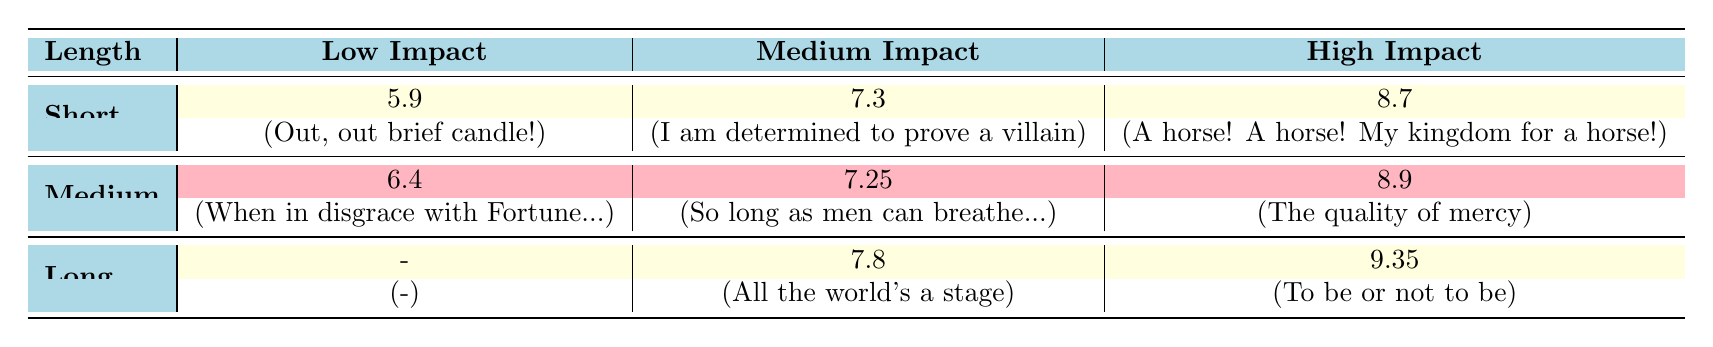What is the audience feedback score for "To be or not to be"? The score for "To be or not to be" is found under the High Impact category in the Long length section of the table, which shows a score of 9.5.
Answer: 9.5 Which emotional impact has the highest rating in the short length category? In the Short length section, the High Impact score is significantly higher than the others, with a score of 8.7 for "A horse! A horse! My kingdom for a horse!".
Answer: High What is the average audience feedback score for medium impact monologues? The medium impact monologues scores are 7.3, 7.25, and 7.8. Summing these gives 22.35, and dividing by 3 gives an average of 7.45.
Answer: 7.45 Is there a low impact monologue with a score higher than 6? "When in disgrace with Fortune and men's eyes" has a score of 6.4, which is greater than 6. Therefore, it is true.
Answer: Yes Which monologue has the shortest length with high emotional impact? The Short length category features one high impact monologue, "A horse! A horse! My kingdom for a horse!", which is 50 seconds long.
Answer: A horse! A horse! My kingdom for a horse! What is the difference in audience feedback scores between the highest and lowest in the low impact category? The highest score in the low impact category is 6.4 for "When in disgrace with Fortune and men's eyes", and the lowest is 5.9 for "Out, out brief candle!". The difference is 6.4 - 5.9 = 0.5.
Answer: 0.5 How many monologues are there in total with a medium emotional impact? The table lists 3 medium impact monologues: "I am determined to prove a villain", "So long as men can breathe or eyes can see", and "All the world's a stage". Thus, there are 3.
Answer: 3 Which emotional impact category has the largest average score across length categories? For a broader examination, the average scores for Low Impact (5.9 + 6.4)/2 = 6.15; Medium Impact (7.3 + 7.25 + 7.8)/3 = 7.45; High Impact (8.7 + 8.9 + 9.5)/3 = 9.03. The highest average is thus for High Impact.
Answer: High Impact Is "Tomorrow, and tomorrow, and tomorrow" included in the short length category? "Tomorrow, and tomorrow, and tomorrow" is listed in the Long length category, not short, confirming it's not included in the short length section.
Answer: No 